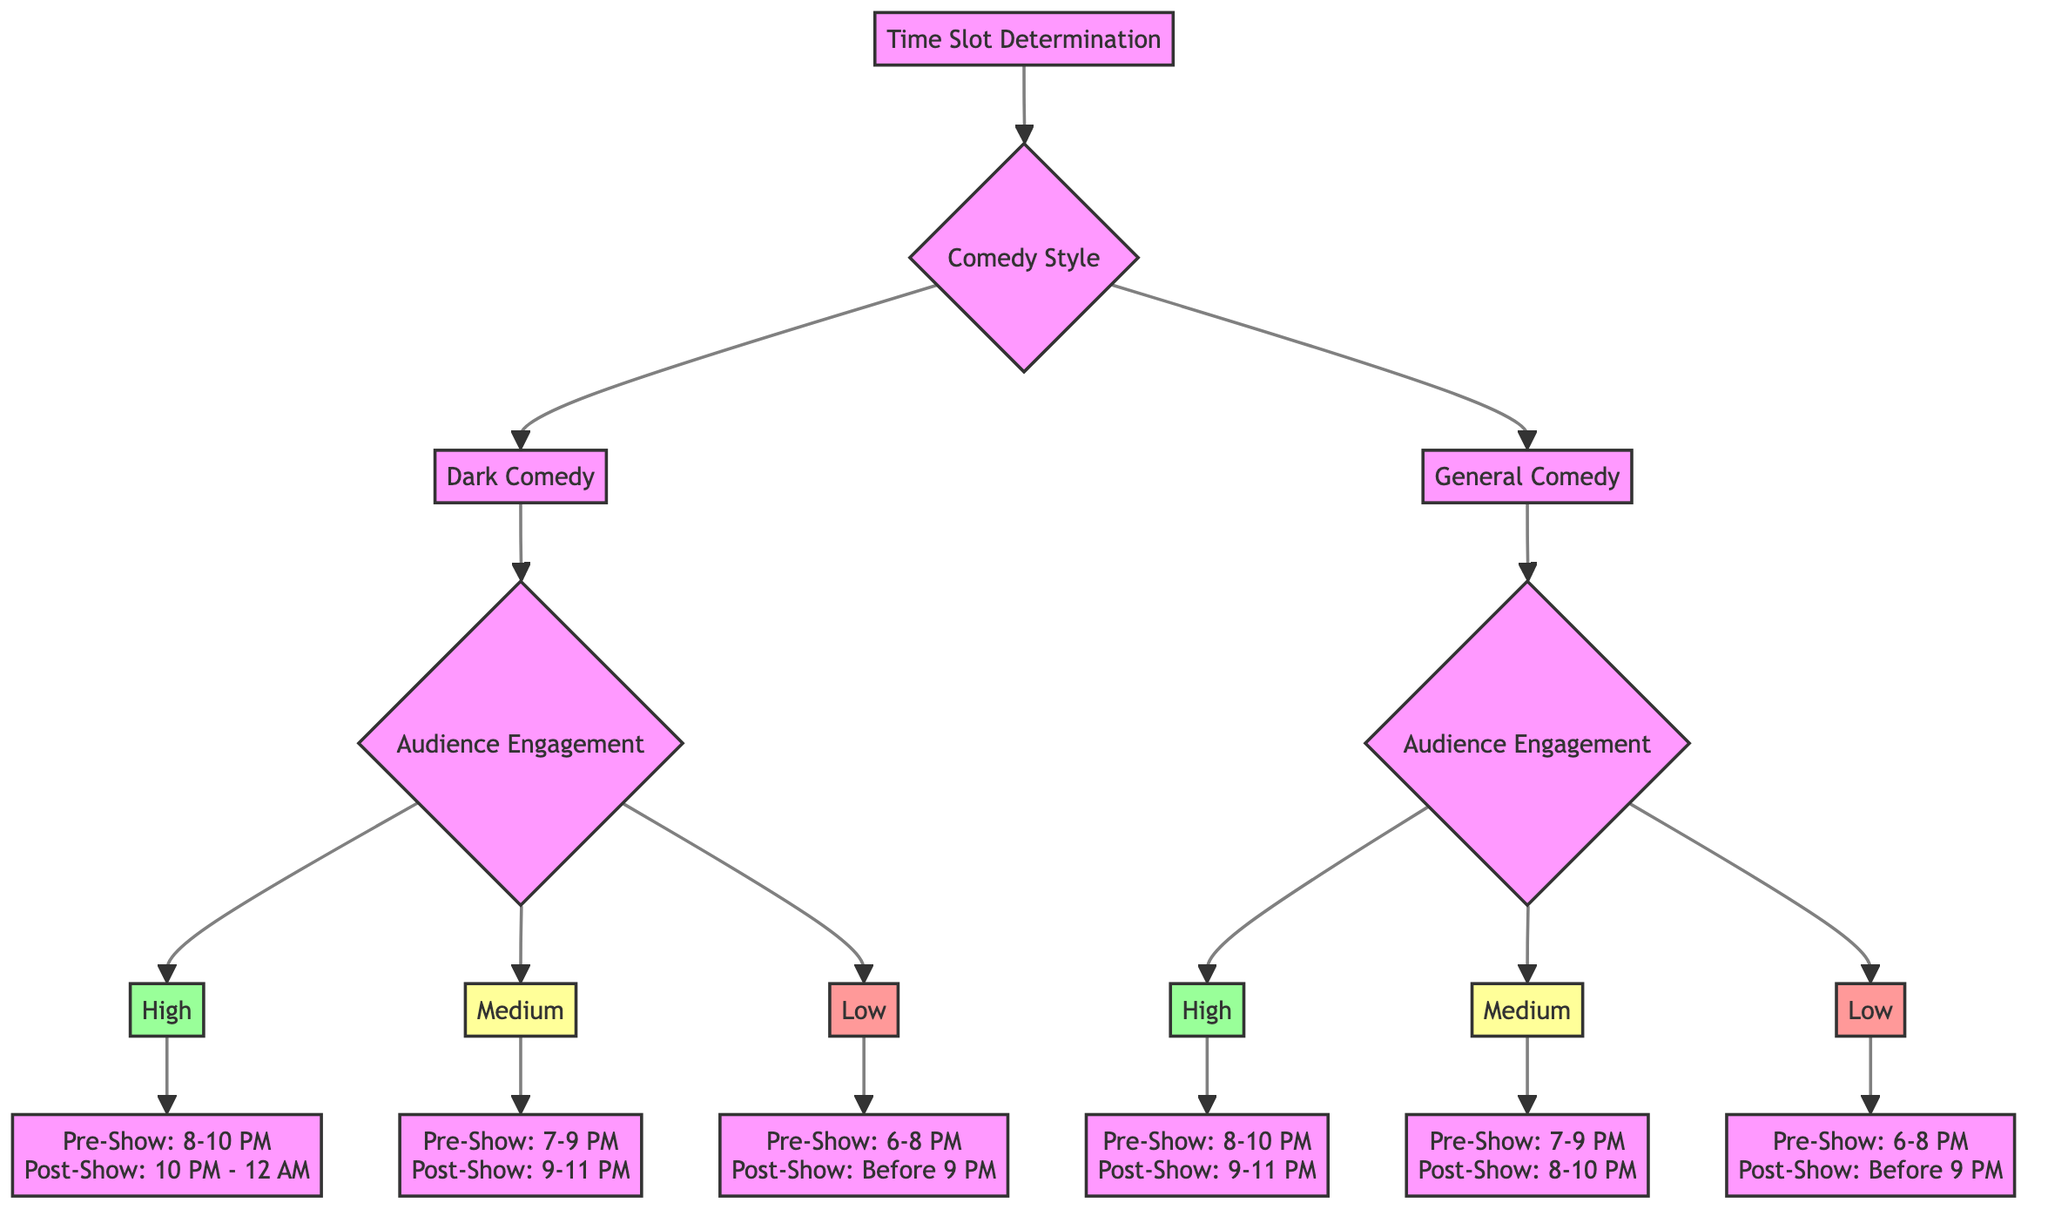What are the preferred pre-show times for high audience engagement in dark comedy? The diagram indicates that for high audience engagement in dark comedy, the preferred pre-show time is 8-10 PM.
Answer: 8-10 PM What is the preferred post-show time for medium audience engagement in general comedy? For medium audience engagement in general comedy, the diagram specifies that the preferred post-show time is 8-10 PM.
Answer: 8-10 PM Which comedy style has a preferred late night post-show time? By examining the diagram, it reveals that dark comedy for high engagement suggests a late night post-show time of 10 PM - 12 AM.
Answer: Dark comedy How many total comedy styles are represented in the diagram? The diagram shows two distinct comedy styles, namely dark comedy and general comedy, as indicated in the first branching node.
Answer: 2 What is the relationship between pre-show surveys and audience engagement levels? The diagram illustrates that pre-show surveys are linked to audience engagement levels, where each engagement level, high, medium, and low, has its own suggested pre-show times based on the engagement status.
Answer: Linked What are the pre-show and post-show times for low audience engagement in dark comedy? According to the diagram, the pre-show time for low audience engagement in dark comedy is 6-8 PM, and the post-show time is before 9 PM.
Answer: Pre-Show: 6-8 PM, Post-Show: Before 9 PM Which audience engagement level corresponds to a preferred post-show time of 9-11 PM in general comedy? Upon analyzing the diagram, it is clear that for general comedy, the preferred post-show time of 9-11 PM corresponds to high audience engagement.
Answer: High What are the reasons given for the preferred pre-show time of 7-9 PM in general comedy? The diagram states that for general comedy with medium engagement, the reason given for the preferred pre-show time of 7-9 PM is that it serves as a good compromise between early and late audience.
Answer: Good compromise between early and late audience What is the feedback time associated with pre-show surveys for low audience engagement in general comedy? The diagram indicates that the feedback time associated with pre-show surveys for low audience engagement in general comedy is from 6-8 PM.
Answer: 6-8 PM 